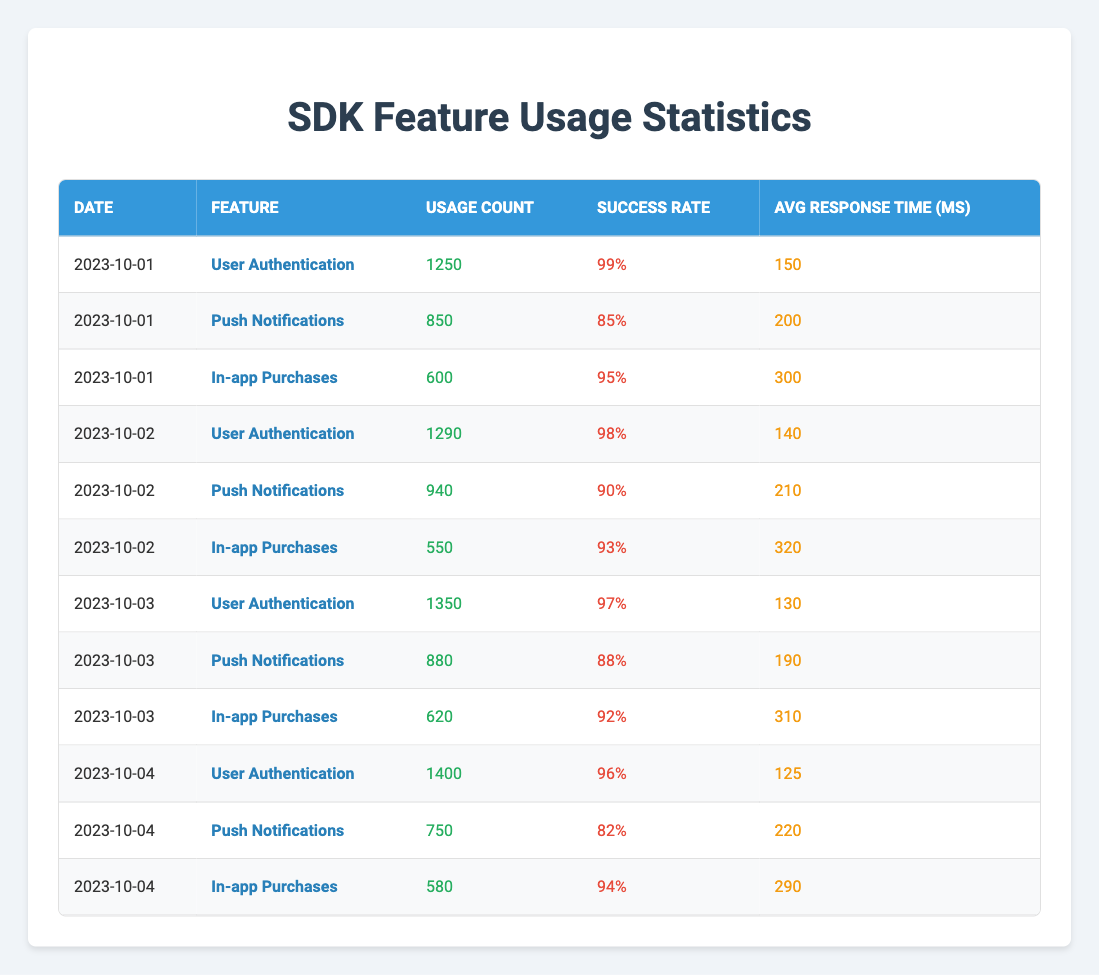What was the usage count for User Authentication on October 04, 2023? On October 04, 2023, the table lists the usage count for the User Authentication feature as 1400.
Answer: 1400 What feature had the highest average response time across the four days? To find the highest average response time, we compare the average response times of all features over the four days: User Authentication (150, 140, 130, 125), Push Notifications (200, 210, 190, 220), and In-app Purchases (300, 320, 310, 290). The highest average response time is for In-app Purchases, which is 305 ms.
Answer: In-app Purchases What is the total usage count of Push Notifications from October 01 to October 04, 2023? We sum the usage counts from the table: 850 (Oct 1) + 940 (Oct 2) + 880 (Oct 3) + 750 (Oct 4) equals 3420.
Answer: 3420 Did In-app Purchases have a success rate above 90% on every day listed? Checking the success rates for In-app Purchases: 95% (Oct 1), 93% (Oct 2), 92% (Oct 3), and 94% (Oct 4) all show rates above 90%.
Answer: Yes What was the average success rate for User Authentication over the four days? We take the success rates for User Authentication: 99% (Oct 1), 98% (Oct 2), 97% (Oct 3), and 96% (Oct 4). Adding them gives us 99 + 98 + 97 + 96 = 390, which divided by 4 yields an average of 97.5%.
Answer: 97.5% Which feature had the lowest usage count on October 02, 2023? Looking at usage counts on October 02, the counts are User Authentication (1290), Push Notifications (940), and In-app Purchases (550). The lowest count is for In-app Purchases at 550.
Answer: In-app Purchases What was the change in usage count for User Authentication from October 01 to October 04, 2023? The usage count for User Authentication on October 01 is 1250, and on October 04 it is 1400. The change is 1400 - 1250 = 150.
Answer: 150 Is there a feature that had a usage count of less than 600 on any day? Checking the data, In-app Purchases has counts of 600 (Oct 1), 550 (Oct 2), 620 (Oct 3), and 580 (Oct 4); thus, it had counts less than 600 on October 2 and 4.
Answer: Yes What was the variation in average response time for Push Notifications from October 01 to October 03? The average response times for Push Notifications are 200 ms (Oct 1), 210 ms (Oct 2), and 190 ms (Oct 3). The variation is (210 - 200) + (200 - 190) = 10 + 10 = 20 ms total.
Answer: 20 ms Did the average response time for In-app Purchases improve over the four days? The average response times for In-app Purchases are 300 ms (Oct 1), 320 ms (Oct 2), 310 ms (Oct 3), and 290 ms (Oct 4). This indicates an initial increase followed by a decrease; thus, it did not improve overall.
Answer: No 